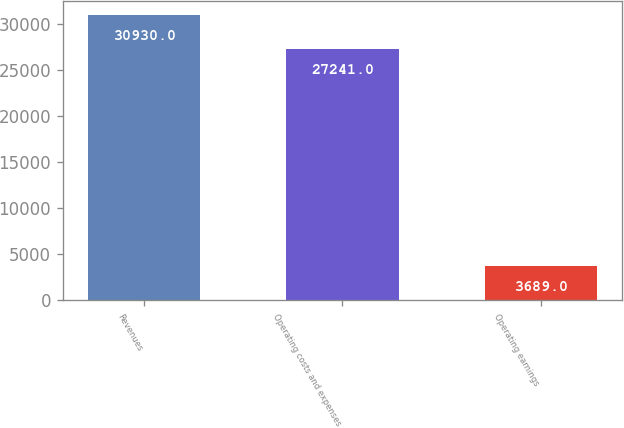Convert chart to OTSL. <chart><loc_0><loc_0><loc_500><loc_500><bar_chart><fcel>Revenues<fcel>Operating costs and expenses<fcel>Operating earnings<nl><fcel>30930<fcel>27241<fcel>3689<nl></chart> 